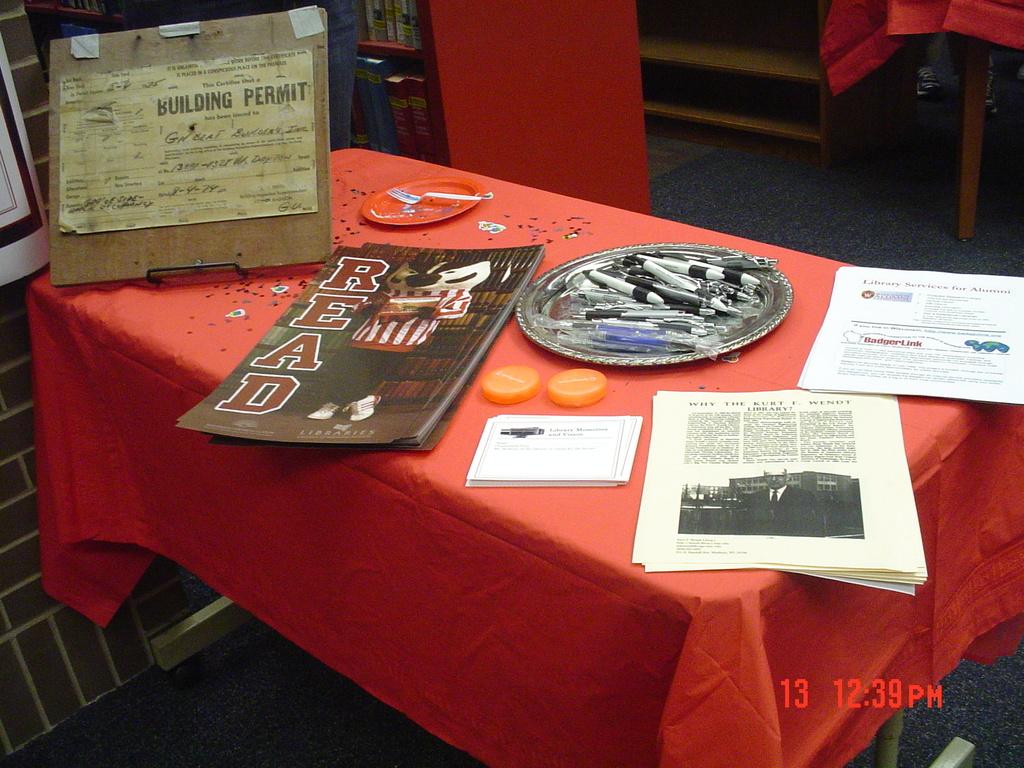What does the long pamphlet say in big letters?
Your answer should be compact. Read. What type of permit is on the far left?
Your answer should be compact. Building. 